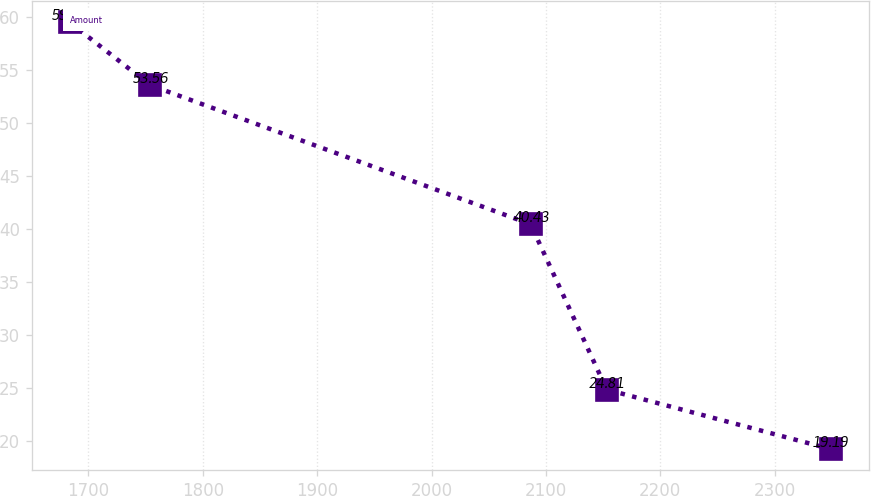<chart> <loc_0><loc_0><loc_500><loc_500><line_chart><ecel><fcel>Amount<nl><fcel>1683.53<fcel>59.49<nl><fcel>1753.95<fcel>53.56<nl><fcel>2086.64<fcel>40.43<nl><fcel>2153.2<fcel>24.81<nl><fcel>2349.1<fcel>19.19<nl></chart> 